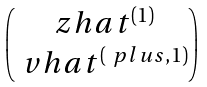<formula> <loc_0><loc_0><loc_500><loc_500>\begin{pmatrix} \ z h a t { ^ { ( 1 ) } } \\ \ v h a t { ^ { ( \ p l u s , 1 ) } } \end{pmatrix}</formula> 